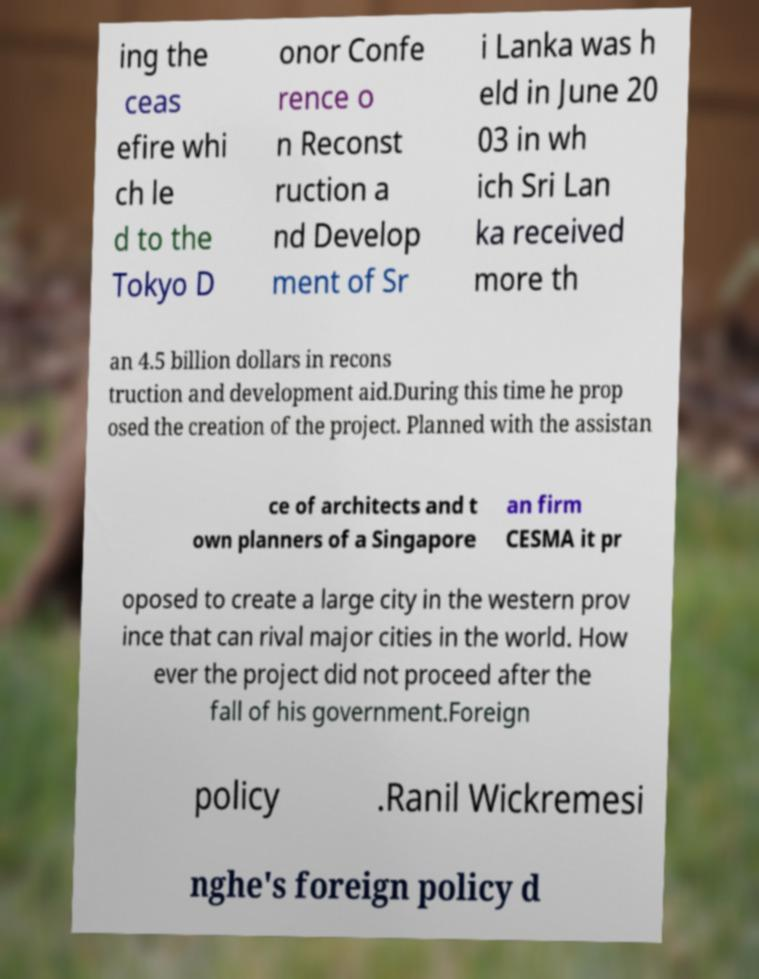For documentation purposes, I need the text within this image transcribed. Could you provide that? ing the ceas efire whi ch le d to the Tokyo D onor Confe rence o n Reconst ruction a nd Develop ment of Sr i Lanka was h eld in June 20 03 in wh ich Sri Lan ka received more th an 4.5 billion dollars in recons truction and development aid.During this time he prop osed the creation of the project. Planned with the assistan ce of architects and t own planners of a Singapore an firm CESMA it pr oposed to create a large city in the western prov ince that can rival major cities in the world. How ever the project did not proceed after the fall of his government.Foreign policy .Ranil Wickremesi nghe's foreign policy d 